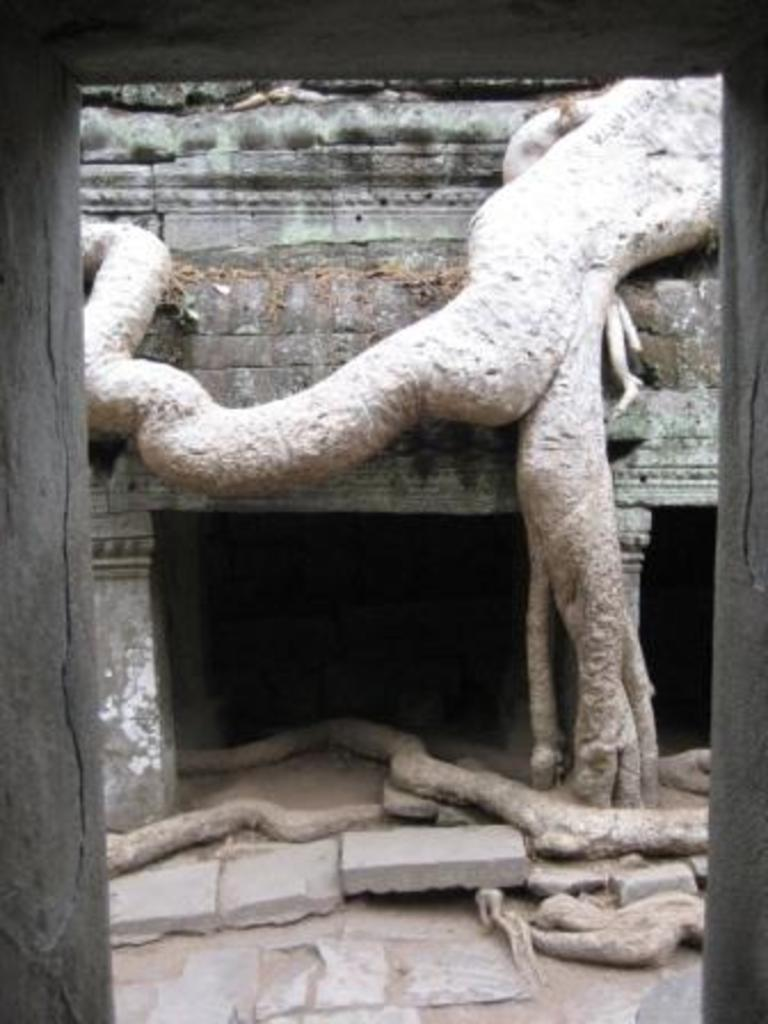What is the main subject of the image? The main subject of the image is a root of a tree. Can you describe any other structures or objects in the image? Yes, there is a building in the image. What type of question is being asked in the image? There is no question present in the image; it features a root of a tree and a building. 